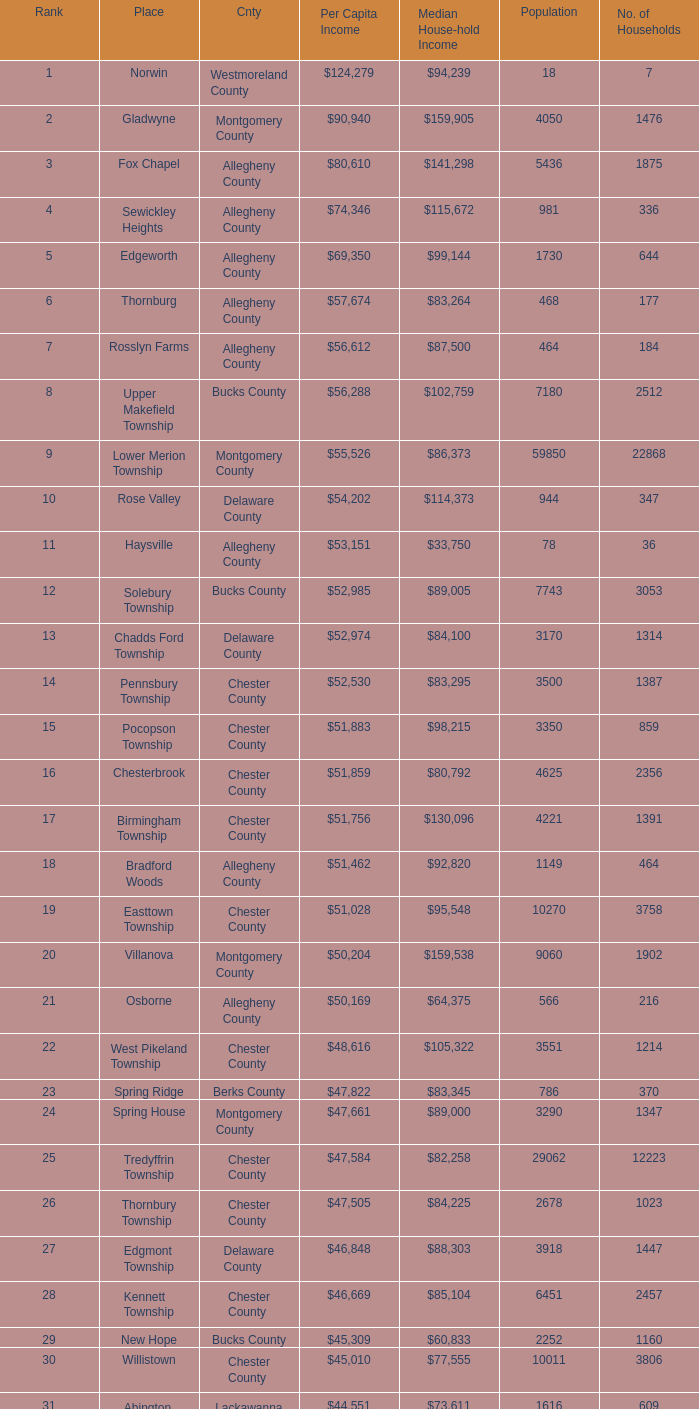What is the median household income for Woodside? $121,151. 